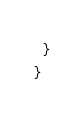Convert code to text. <code><loc_0><loc_0><loc_500><loc_500><_Scala_>  }
}

</code> 